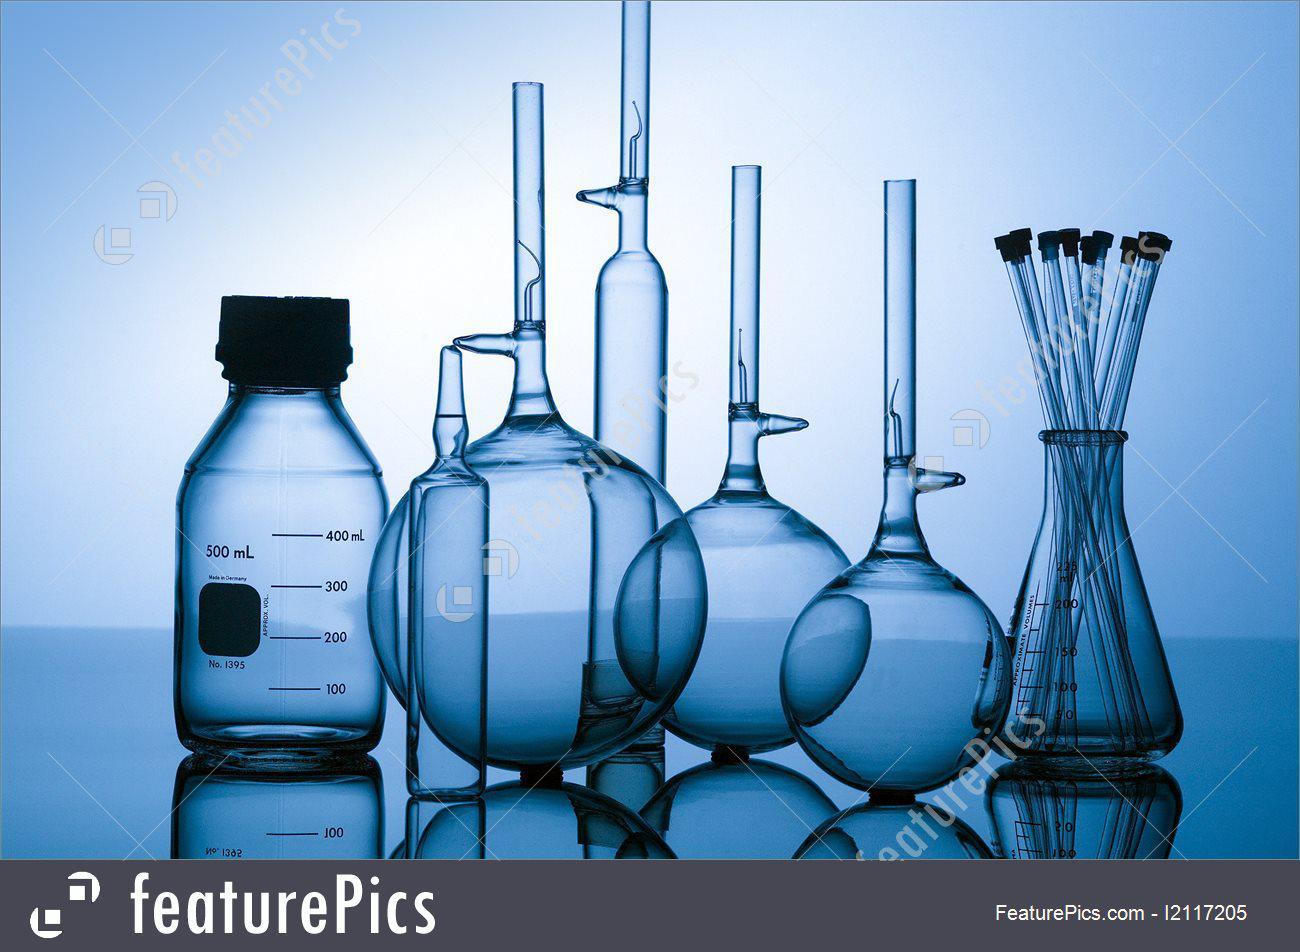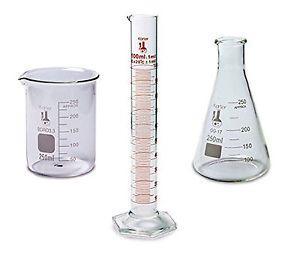The first image is the image on the left, the second image is the image on the right. For the images displayed, is the sentence "The containers in the image on the left are set up near a blue light." factually correct? Answer yes or no. Yes. The first image is the image on the left, the second image is the image on the right. Given the left and right images, does the statement "There are exactly three object in one of the images." hold true? Answer yes or no. Yes. 